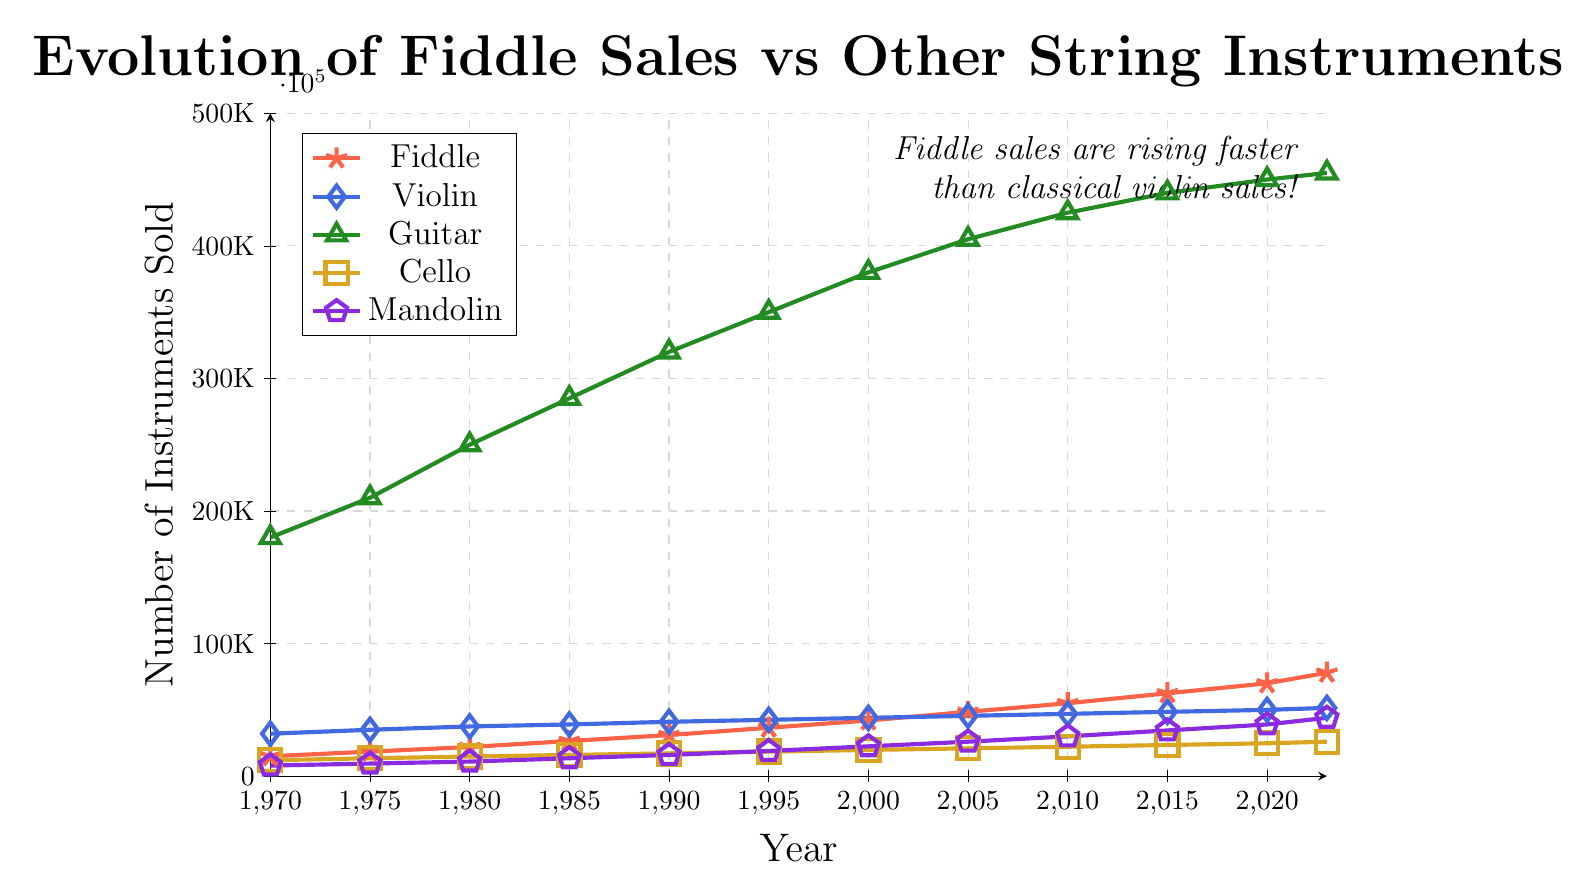How do fiddle sales compare to violin sales in the present year? Fiddle sales are marked with stars in red, and violin sales are marked with diamonds in blue. Looking at the present year, we can see fiddle sales are 78,000 and violin sales are 51,500. Hence, fiddle sales are higher.
Answer: Fiddle sales are higher Which string instrument has shown the most significant increase in sales from 1970 to the present? To find out which instrument has shown the most significant increase, we need to look at the difference in sales from 1970 to the present for each instrument. Guitar sales increased from 180,000 to 455,000; Fiddle from 15,000 to 78,000; Violin from 32,000 to 51,500; Cello from 12,000 to 26,000; Mandolin from 8,000 to 44,000. The guitar shows the largest increase in numbers.
Answer: Guitar How much have fiddle sales increased from 1970 to the present? Fiddle sales in 1970 were 15,000, and in the present year, they are 78,000. The increase is calculated as 78,000 - 15,000 = 63,000.
Answer: 63,000 By how much did fiddle sales differ from guitar sales in 2020? In 2020, fiddle sales were 70,000 and guitar sales were 450,000. The difference is calculated as 450,000 - 70,000 = 380,000.
Answer: 380,000 Which instrument had the least sales increase over the entire period? We need to compare the increase in sales for each instrument from 1970 to the present. Fiddle increased by 63,000, Violin by 19,500, Guitar by 275,000, Cello by 14,000, and Mandolin by 36,000. The violin had the least increase.
Answer: Violin What is the average annual increase in fiddle sales between each recorded period? The fiddle sales data points are: 15,000 (1970), 18,500 (1975), 22,000 (1980), 26,500 (1985), 31,000 (1990), 36,500 (1995), 42,000 (2000), 48,500 (2005), 55,000 (2010), 62,500 (2015), 70,000 (2020), 78,000 (present). First, determine the period count (52 years from 1970 to 2023 equally spaced 12 intervals). Average annual increase is calculated as total increase (78,000 - 15,000 = 63,000) divided by 52 years: 63,000 / 52 ≈ 1,211.
Answer: 1,211 In which year did fiddle sales first exceed 50,000? Referring to the data points of fiddle sales, 50,000 was first exceeded between the years 2005 (48,500) and 2010 (55,000).
Answer: 2010 Which instrument has shown more consistent sales growth over time, fiddle or violin? Both fiddle and violin sales have increased over time, but to determine consistency, we need to look at the smoothness of the line and absence of sudden rises or drops. Both lines look smooth, but fiddles show a more steady upward trend without sharp rises or falls.
Answer: Fiddle 